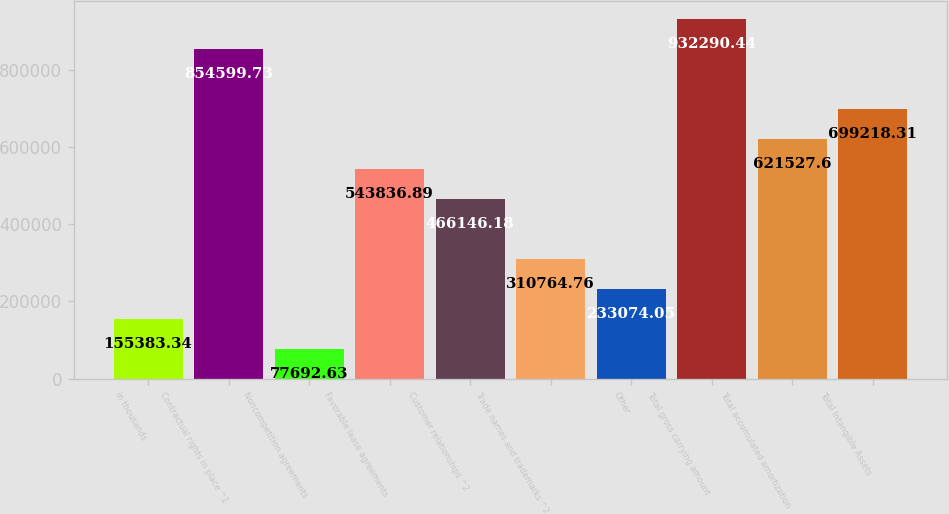Convert chart to OTSL. <chart><loc_0><loc_0><loc_500><loc_500><bar_chart><fcel>in thousands<fcel>Contractual rights in place ^1<fcel>Noncompetition agreements<fcel>Favorable lease agreements<fcel>Customer relationships ^2<fcel>Trade names and trademarks ^2<fcel>Other<fcel>Total gross carrying amount<fcel>Total accumulated amortization<fcel>Total Intangible Assets<nl><fcel>155383<fcel>854600<fcel>77692.6<fcel>543837<fcel>466146<fcel>310765<fcel>233074<fcel>932290<fcel>621528<fcel>699218<nl></chart> 